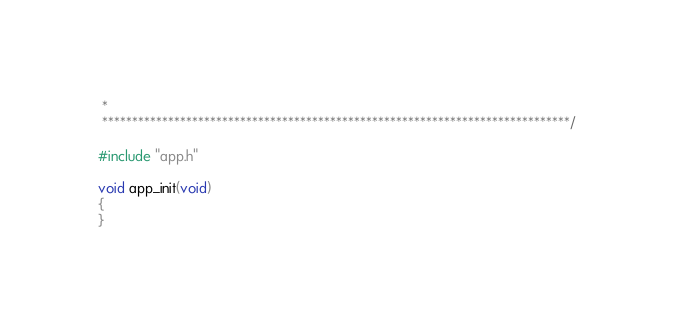<code> <loc_0><loc_0><loc_500><loc_500><_C_> *
 ******************************************************************************/

#include "app.h"

void app_init(void)
{
}
</code> 